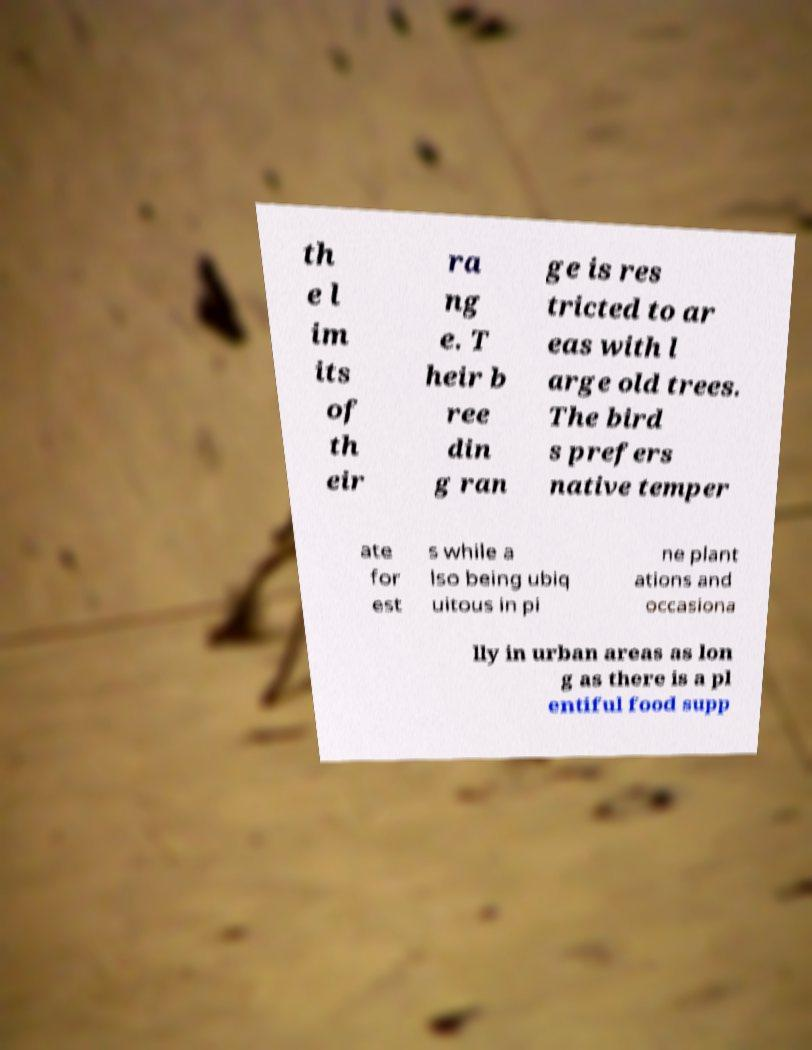I need the written content from this picture converted into text. Can you do that? th e l im its of th eir ra ng e. T heir b ree din g ran ge is res tricted to ar eas with l arge old trees. The bird s prefers native temper ate for est s while a lso being ubiq uitous in pi ne plant ations and occasiona lly in urban areas as lon g as there is a pl entiful food supp 